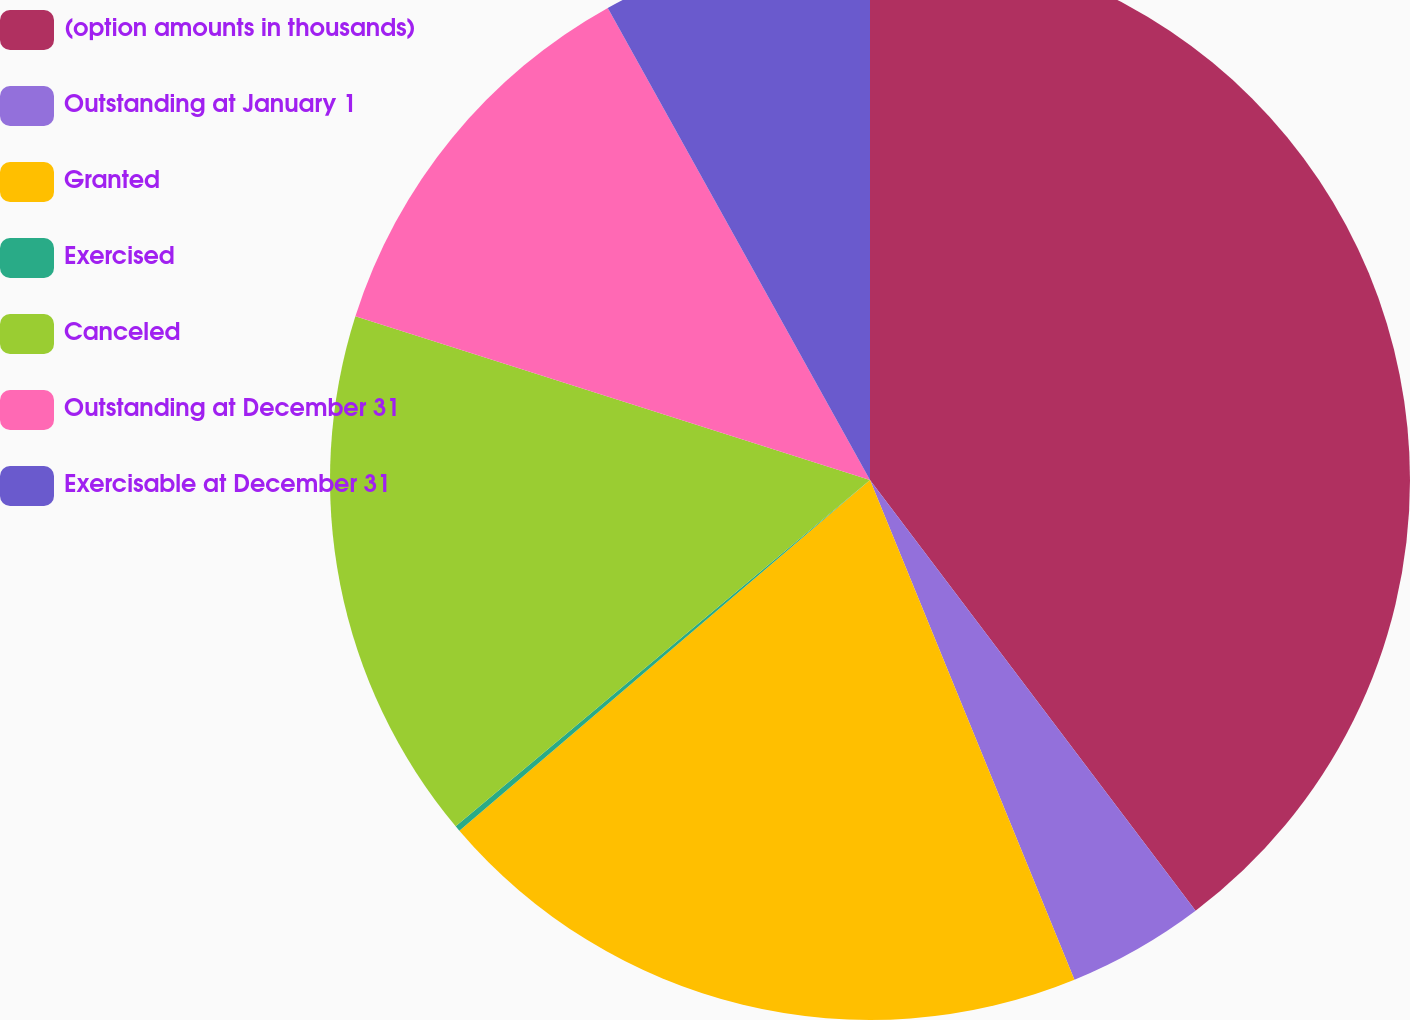Convert chart. <chart><loc_0><loc_0><loc_500><loc_500><pie_chart><fcel>(option amounts in thousands)<fcel>Outstanding at January 1<fcel>Granted<fcel>Exercised<fcel>Canceled<fcel>Outstanding at December 31<fcel>Exercisable at December 31<nl><fcel>39.7%<fcel>4.12%<fcel>19.93%<fcel>0.17%<fcel>15.98%<fcel>12.03%<fcel>8.07%<nl></chart> 